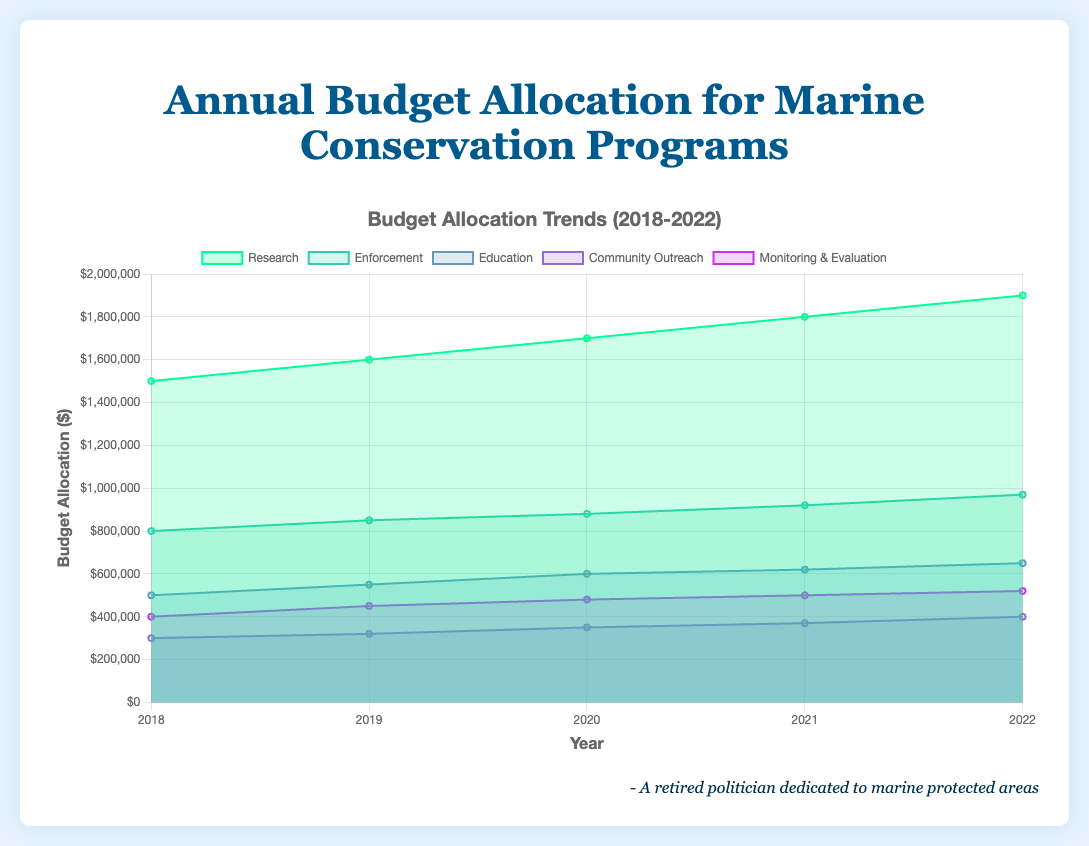what are the different categories of budget allocations in the figure? The figure displays the annual budget allocation for marine conservation programs. The different categories of budget allocations are visualized distinctly.
Answer: The categories are Research, Enforcement, Education, Community Outreach, and Monitoring & Evaluation What is the title of the chart? The title is prominently displayed at the top of the chart.
Answer: Annual Budget Allocation for Marine Conservation Programs How much was allocated to Research in 2020? To find this, refer to the data points along the 'Research' line for the year 2020.
Answer: $1,700,000 Which category had the lowest budget allocation in 2019? By comparing the budget allocations for all categories in 2019, the category with the smallest value is identified.
Answer: Community Outreach How did the budget allocation for Enforcement change from 2018 to 2022? Compare the budget values for Enforcement in 2018 and 2022 to observe the change.
Answer: Increased by $170,000 What is the total budget allocation for Community Outreach across all the years? To get the total, sum up all the annual budget allocations for Community Outreach from 2018 to 2022.
Answer: $1,740,000 Which category consistently received increases in its budget allocation each year? Analyze the budget allocation trends for each category. The category with a yearly increase in budget is identified.
Answer: Research How much more was allocated to Research than to Education in 2022? Subtract the budget allocation for Education from that of Research for 2022.
Answer: $1,250,000 What was the total budget allocation for all categories in 2021? Sum the budget allocations of all categories for the year 2021.
Answer: $4,870,000 Is the trend of budget allocation for Monitoring & Evaluation increasing, decreasing, or inconsistent over the years? Examine the budget allocation trend for Monitoring & Evaluation from 2018 to 2022 to determine the pattern.
Answer: Increasing 